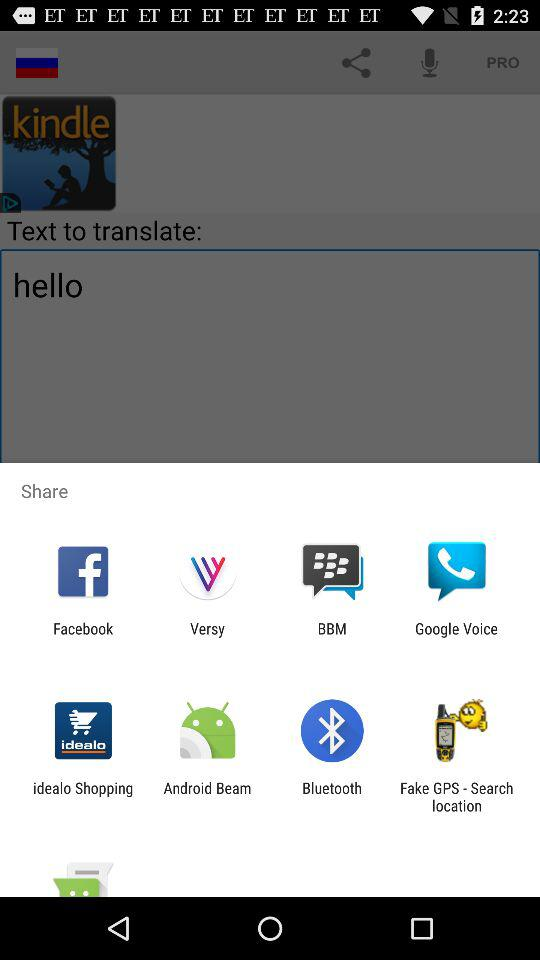Who is this application powered by?
When the provided information is insufficient, respond with <no answer>. <no answer> 